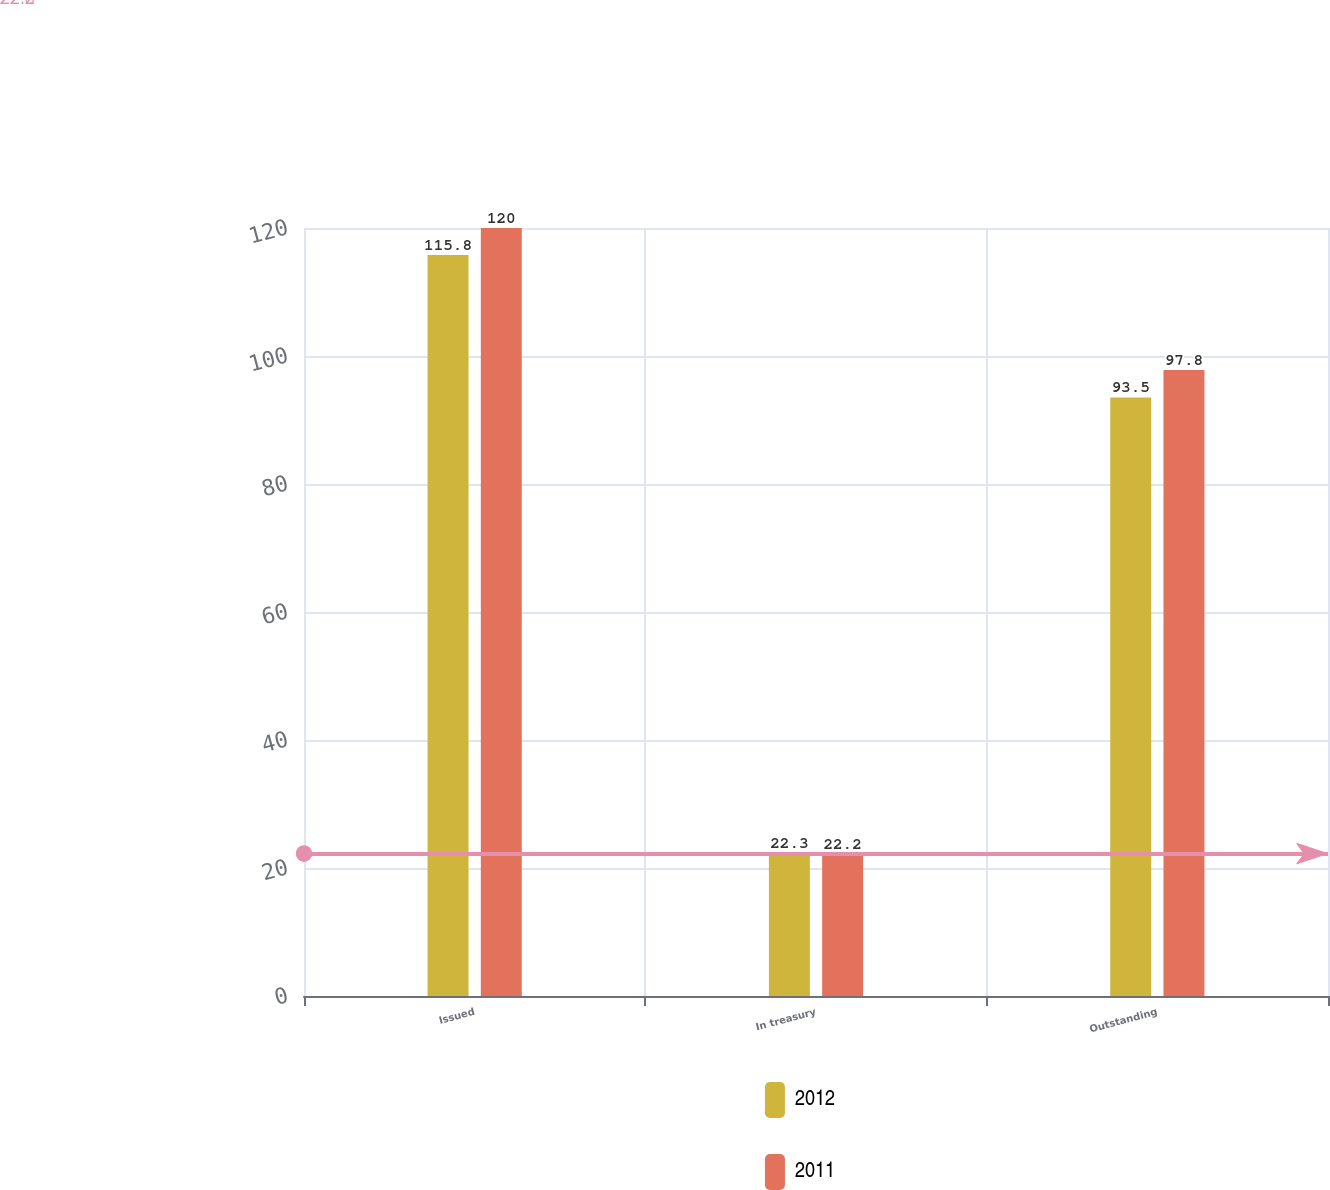Convert chart to OTSL. <chart><loc_0><loc_0><loc_500><loc_500><stacked_bar_chart><ecel><fcel>Issued<fcel>In treasury<fcel>Outstanding<nl><fcel>2012<fcel>115.8<fcel>22.3<fcel>93.5<nl><fcel>2011<fcel>120<fcel>22.2<fcel>97.8<nl></chart> 